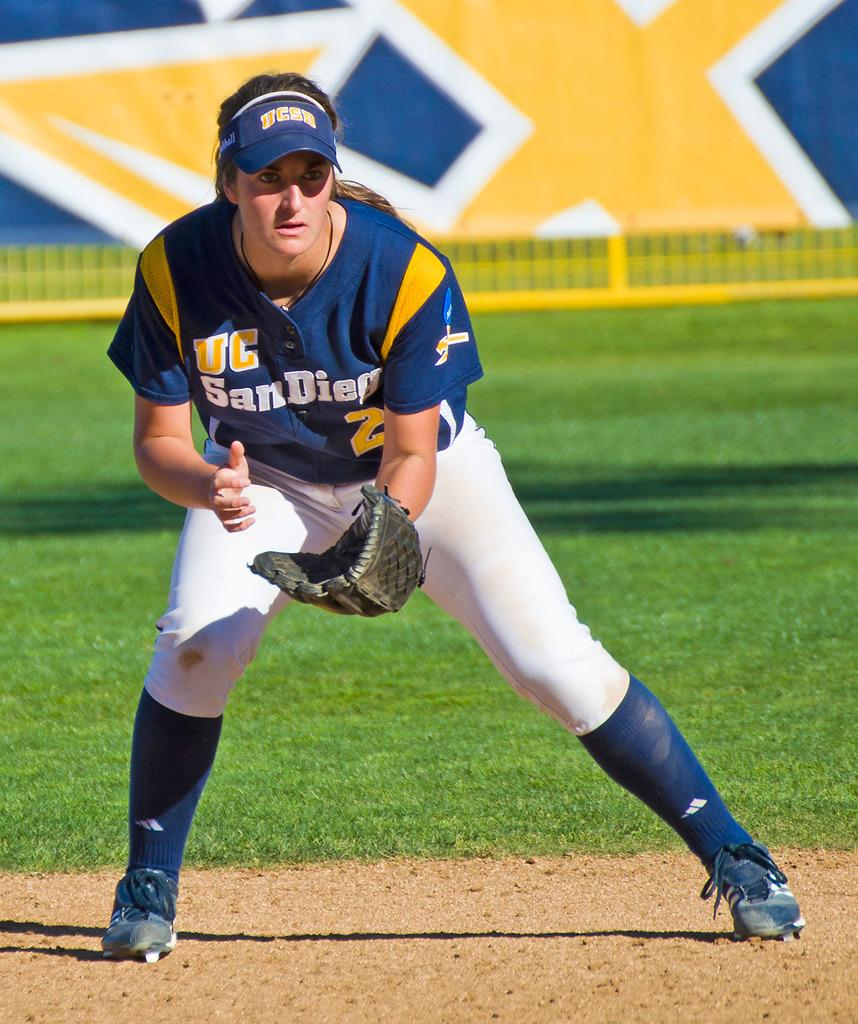<image>
Offer a succinct explanation of the picture presented. A UC San Diego baseball player is ready for the ball. 